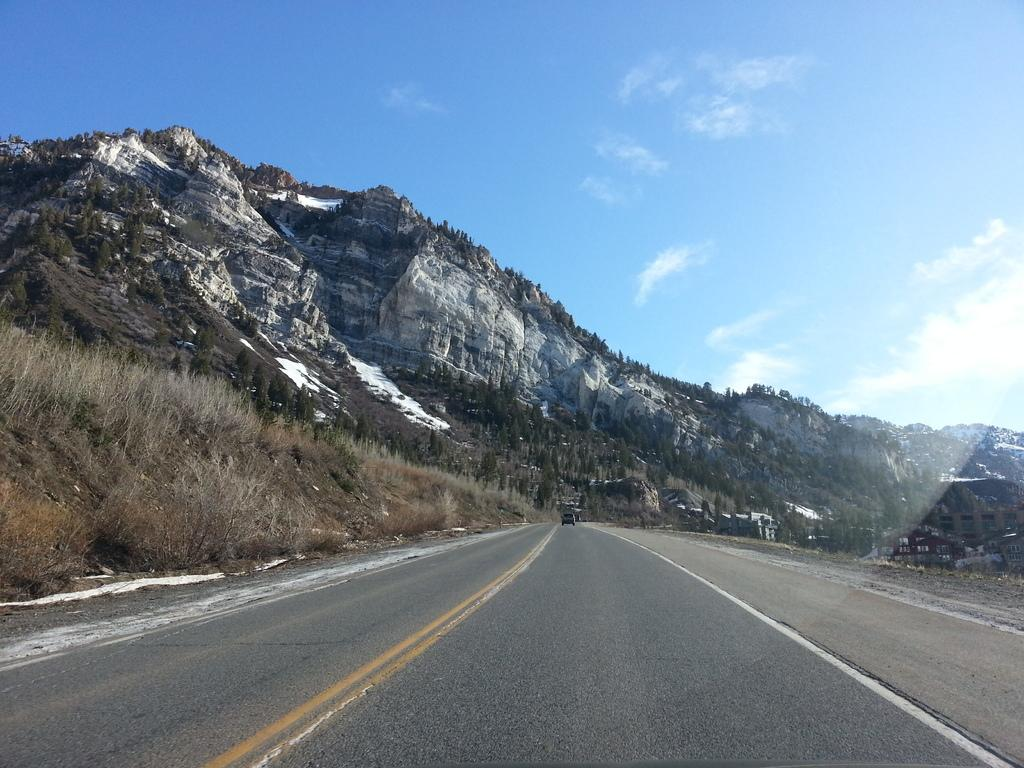What is the main feature of the image? There is a road in the image. What can be seen in the background of the image? Mountains surround the road in the image. What type of bed is visible in the image? There is no bed present in the image; it features a road with mountains in the background. 